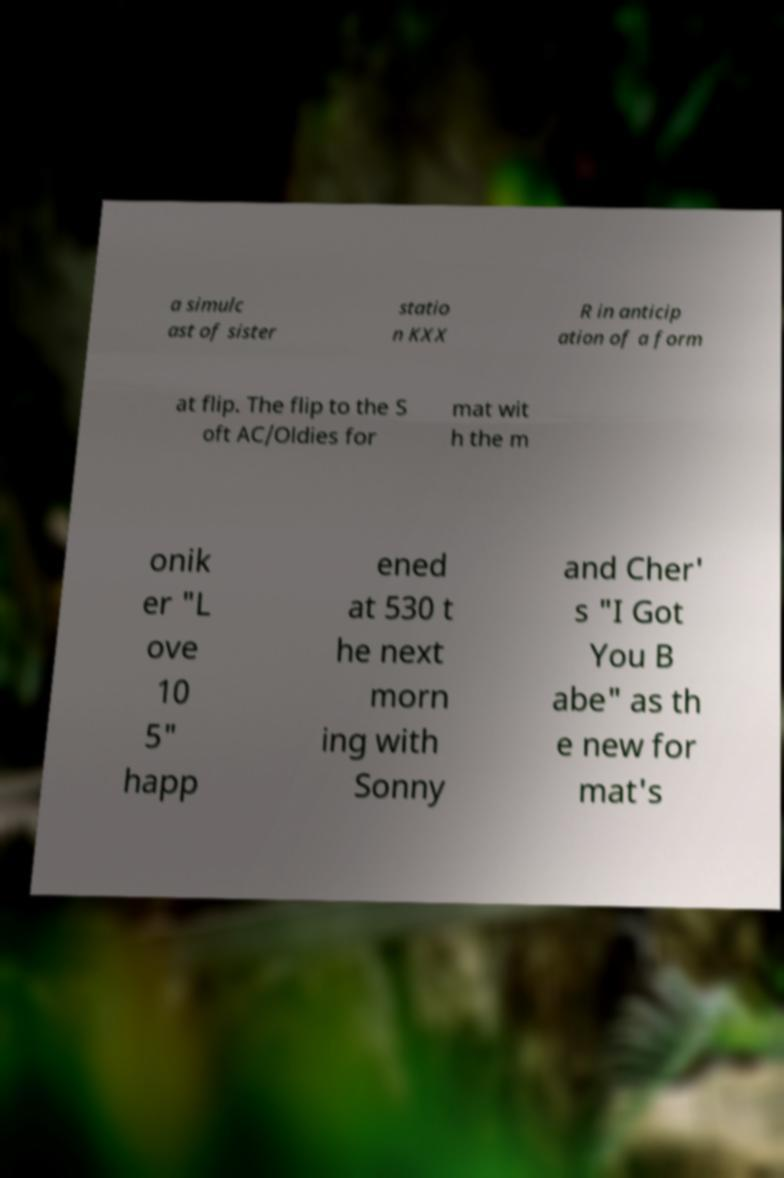Please read and relay the text visible in this image. What does it say? a simulc ast of sister statio n KXX R in anticip ation of a form at flip. The flip to the S oft AC/Oldies for mat wit h the m onik er "L ove 10 5" happ ened at 530 t he next morn ing with Sonny and Cher' s "I Got You B abe" as th e new for mat's 